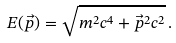Convert formula to latex. <formula><loc_0><loc_0><loc_500><loc_500>E ( \vec { p } ) = \sqrt { m ^ { 2 } c ^ { 4 } + \vec { p } ^ { 2 } c ^ { 2 } } \, .</formula> 